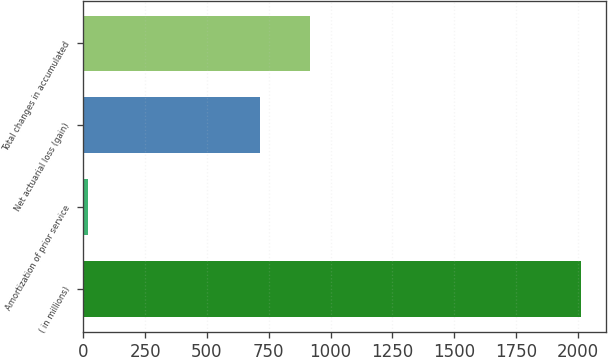<chart> <loc_0><loc_0><loc_500><loc_500><bar_chart><fcel>( in millions)<fcel>Amortization of prior service<fcel>Net actuarial loss (gain)<fcel>Total changes in accumulated<nl><fcel>2013<fcel>18<fcel>716<fcel>915.5<nl></chart> 